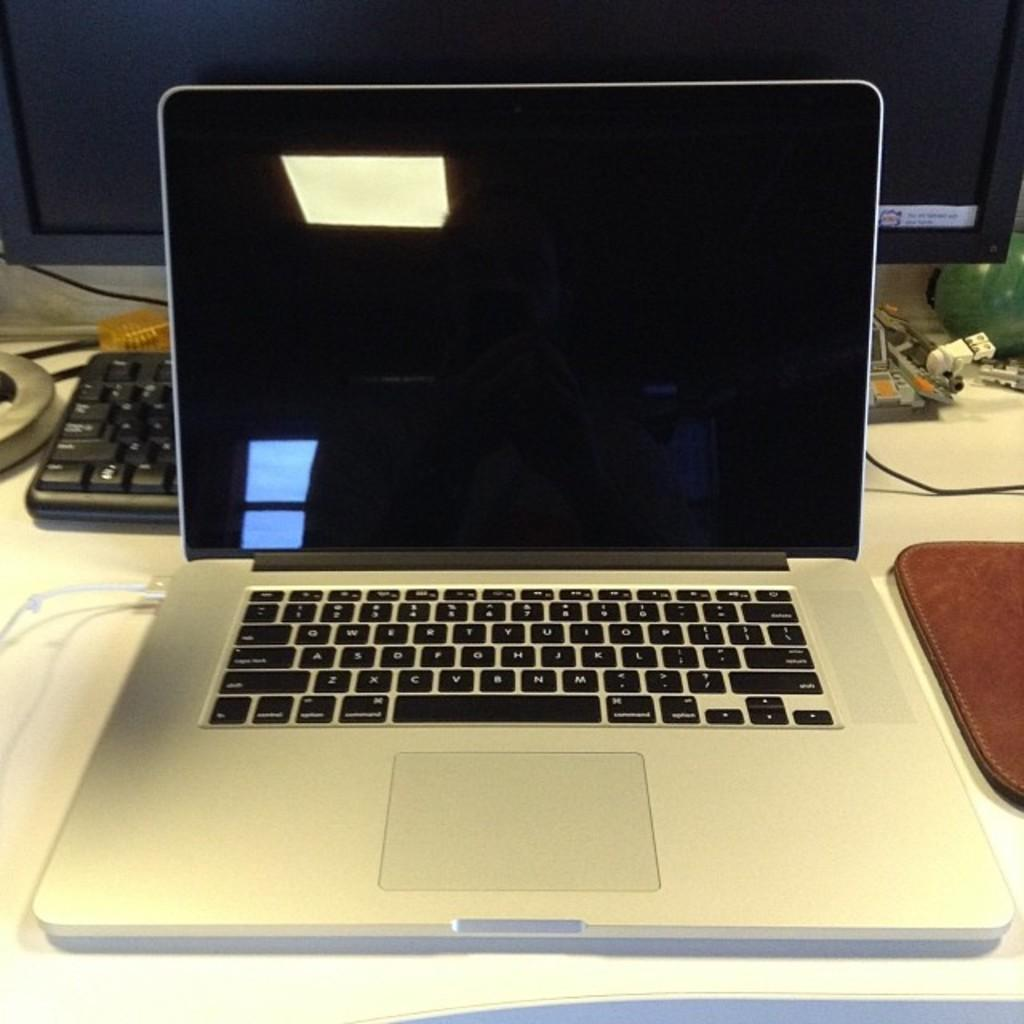<image>
Offer a succinct explanation of the picture presented. a keyboard with the letter z on the left side 